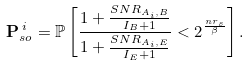<formula> <loc_0><loc_0><loc_500><loc_500>\mathbf P _ { s o } ^ { \, i } = \mathbb { P } \left [ \frac { 1 + \frac { S N R _ { A _ { i } , B } } { I _ { B } + 1 } } { 1 + \frac { S N R _ { A _ { i } , E } } { I _ { E } + 1 } } < 2 ^ { \frac { n r _ { s } } { \beta } } \right ] .</formula> 